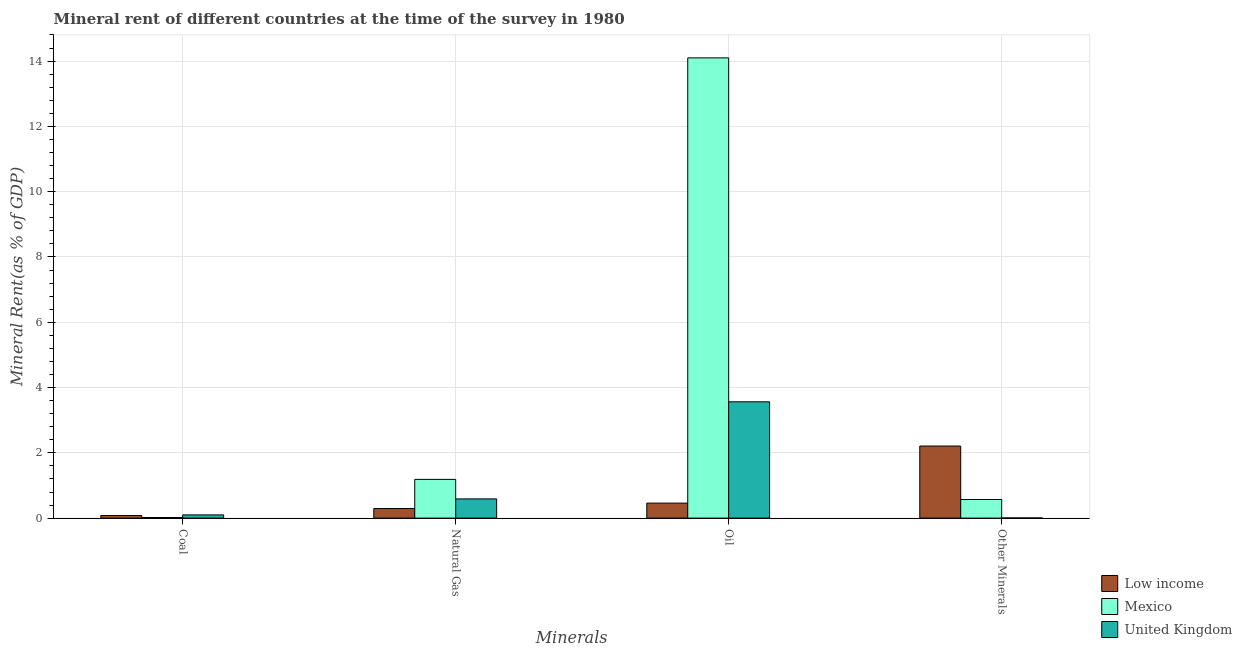How many different coloured bars are there?
Keep it short and to the point. 3. Are the number of bars on each tick of the X-axis equal?
Provide a succinct answer. Yes. What is the label of the 4th group of bars from the left?
Give a very brief answer. Other Minerals. What is the  rent of other minerals in United Kingdom?
Give a very brief answer. 0. Across all countries, what is the maximum natural gas rent?
Offer a terse response. 1.19. Across all countries, what is the minimum  rent of other minerals?
Give a very brief answer. 0. In which country was the coal rent maximum?
Give a very brief answer. United Kingdom. What is the total coal rent in the graph?
Your answer should be very brief. 0.2. What is the difference between the  rent of other minerals in Mexico and that in United Kingdom?
Your answer should be compact. 0.57. What is the difference between the oil rent in United Kingdom and the  rent of other minerals in Mexico?
Your response must be concise. 2.99. What is the average  rent of other minerals per country?
Your answer should be very brief. 0.93. What is the difference between the natural gas rent and  rent of other minerals in United Kingdom?
Provide a short and direct response. 0.58. In how many countries, is the oil rent greater than 7.6 %?
Ensure brevity in your answer.  1. What is the ratio of the natural gas rent in Low income to that in Mexico?
Offer a terse response. 0.25. What is the difference between the highest and the second highest coal rent?
Make the answer very short. 0.02. What is the difference between the highest and the lowest  rent of other minerals?
Your response must be concise. 2.2. Is it the case that in every country, the sum of the natural gas rent and  rent of other minerals is greater than the sum of coal rent and oil rent?
Give a very brief answer. No. What does the 2nd bar from the left in Oil represents?
Provide a short and direct response. Mexico. Is it the case that in every country, the sum of the coal rent and natural gas rent is greater than the oil rent?
Offer a terse response. No. Are all the bars in the graph horizontal?
Keep it short and to the point. No. What is the difference between two consecutive major ticks on the Y-axis?
Provide a succinct answer. 2. Where does the legend appear in the graph?
Provide a short and direct response. Bottom right. How many legend labels are there?
Ensure brevity in your answer.  3. How are the legend labels stacked?
Make the answer very short. Vertical. What is the title of the graph?
Make the answer very short. Mineral rent of different countries at the time of the survey in 1980. What is the label or title of the X-axis?
Your response must be concise. Minerals. What is the label or title of the Y-axis?
Ensure brevity in your answer.  Mineral Rent(as % of GDP). What is the Mineral Rent(as % of GDP) of Low income in Coal?
Your response must be concise. 0.08. What is the Mineral Rent(as % of GDP) of Mexico in Coal?
Keep it short and to the point. 0.02. What is the Mineral Rent(as % of GDP) of United Kingdom in Coal?
Give a very brief answer. 0.1. What is the Mineral Rent(as % of GDP) in Low income in Natural Gas?
Your response must be concise. 0.29. What is the Mineral Rent(as % of GDP) in Mexico in Natural Gas?
Offer a very short reply. 1.19. What is the Mineral Rent(as % of GDP) of United Kingdom in Natural Gas?
Your response must be concise. 0.59. What is the Mineral Rent(as % of GDP) in Low income in Oil?
Your answer should be very brief. 0.46. What is the Mineral Rent(as % of GDP) of Mexico in Oil?
Keep it short and to the point. 14.1. What is the Mineral Rent(as % of GDP) in United Kingdom in Oil?
Provide a short and direct response. 3.56. What is the Mineral Rent(as % of GDP) in Low income in Other Minerals?
Offer a very short reply. 2.21. What is the Mineral Rent(as % of GDP) of Mexico in Other Minerals?
Give a very brief answer. 0.57. What is the Mineral Rent(as % of GDP) in United Kingdom in Other Minerals?
Your response must be concise. 0. Across all Minerals, what is the maximum Mineral Rent(as % of GDP) in Low income?
Make the answer very short. 2.21. Across all Minerals, what is the maximum Mineral Rent(as % of GDP) of Mexico?
Provide a succinct answer. 14.1. Across all Minerals, what is the maximum Mineral Rent(as % of GDP) of United Kingdom?
Your answer should be compact. 3.56. Across all Minerals, what is the minimum Mineral Rent(as % of GDP) in Low income?
Make the answer very short. 0.08. Across all Minerals, what is the minimum Mineral Rent(as % of GDP) of Mexico?
Offer a very short reply. 0.02. Across all Minerals, what is the minimum Mineral Rent(as % of GDP) in United Kingdom?
Offer a terse response. 0. What is the total Mineral Rent(as % of GDP) in Low income in the graph?
Give a very brief answer. 3.04. What is the total Mineral Rent(as % of GDP) in Mexico in the graph?
Your answer should be compact. 15.87. What is the total Mineral Rent(as % of GDP) in United Kingdom in the graph?
Keep it short and to the point. 4.26. What is the difference between the Mineral Rent(as % of GDP) in Low income in Coal and that in Natural Gas?
Provide a short and direct response. -0.21. What is the difference between the Mineral Rent(as % of GDP) in Mexico in Coal and that in Natural Gas?
Provide a succinct answer. -1.17. What is the difference between the Mineral Rent(as % of GDP) in United Kingdom in Coal and that in Natural Gas?
Make the answer very short. -0.49. What is the difference between the Mineral Rent(as % of GDP) of Low income in Coal and that in Oil?
Give a very brief answer. -0.38. What is the difference between the Mineral Rent(as % of GDP) in Mexico in Coal and that in Oil?
Offer a very short reply. -14.08. What is the difference between the Mineral Rent(as % of GDP) in United Kingdom in Coal and that in Oil?
Offer a terse response. -3.46. What is the difference between the Mineral Rent(as % of GDP) in Low income in Coal and that in Other Minerals?
Your answer should be very brief. -2.13. What is the difference between the Mineral Rent(as % of GDP) of Mexico in Coal and that in Other Minerals?
Make the answer very short. -0.55. What is the difference between the Mineral Rent(as % of GDP) in United Kingdom in Coal and that in Other Minerals?
Offer a very short reply. 0.09. What is the difference between the Mineral Rent(as % of GDP) in Low income in Natural Gas and that in Oil?
Make the answer very short. -0.16. What is the difference between the Mineral Rent(as % of GDP) in Mexico in Natural Gas and that in Oil?
Ensure brevity in your answer.  -12.91. What is the difference between the Mineral Rent(as % of GDP) of United Kingdom in Natural Gas and that in Oil?
Provide a succinct answer. -2.97. What is the difference between the Mineral Rent(as % of GDP) of Low income in Natural Gas and that in Other Minerals?
Your answer should be compact. -1.91. What is the difference between the Mineral Rent(as % of GDP) of Mexico in Natural Gas and that in Other Minerals?
Make the answer very short. 0.62. What is the difference between the Mineral Rent(as % of GDP) in United Kingdom in Natural Gas and that in Other Minerals?
Offer a terse response. 0.58. What is the difference between the Mineral Rent(as % of GDP) in Low income in Oil and that in Other Minerals?
Offer a very short reply. -1.75. What is the difference between the Mineral Rent(as % of GDP) of Mexico in Oil and that in Other Minerals?
Keep it short and to the point. 13.53. What is the difference between the Mineral Rent(as % of GDP) of United Kingdom in Oil and that in Other Minerals?
Provide a succinct answer. 3.56. What is the difference between the Mineral Rent(as % of GDP) in Low income in Coal and the Mineral Rent(as % of GDP) in Mexico in Natural Gas?
Your response must be concise. -1.11. What is the difference between the Mineral Rent(as % of GDP) of Low income in Coal and the Mineral Rent(as % of GDP) of United Kingdom in Natural Gas?
Ensure brevity in your answer.  -0.51. What is the difference between the Mineral Rent(as % of GDP) of Mexico in Coal and the Mineral Rent(as % of GDP) of United Kingdom in Natural Gas?
Make the answer very short. -0.57. What is the difference between the Mineral Rent(as % of GDP) in Low income in Coal and the Mineral Rent(as % of GDP) in Mexico in Oil?
Your answer should be compact. -14.02. What is the difference between the Mineral Rent(as % of GDP) in Low income in Coal and the Mineral Rent(as % of GDP) in United Kingdom in Oil?
Offer a very short reply. -3.48. What is the difference between the Mineral Rent(as % of GDP) of Mexico in Coal and the Mineral Rent(as % of GDP) of United Kingdom in Oil?
Offer a terse response. -3.54. What is the difference between the Mineral Rent(as % of GDP) in Low income in Coal and the Mineral Rent(as % of GDP) in Mexico in Other Minerals?
Provide a short and direct response. -0.49. What is the difference between the Mineral Rent(as % of GDP) of Low income in Coal and the Mineral Rent(as % of GDP) of United Kingdom in Other Minerals?
Provide a short and direct response. 0.08. What is the difference between the Mineral Rent(as % of GDP) of Mexico in Coal and the Mineral Rent(as % of GDP) of United Kingdom in Other Minerals?
Make the answer very short. 0.01. What is the difference between the Mineral Rent(as % of GDP) in Low income in Natural Gas and the Mineral Rent(as % of GDP) in Mexico in Oil?
Offer a very short reply. -13.8. What is the difference between the Mineral Rent(as % of GDP) of Low income in Natural Gas and the Mineral Rent(as % of GDP) of United Kingdom in Oil?
Ensure brevity in your answer.  -3.27. What is the difference between the Mineral Rent(as % of GDP) of Mexico in Natural Gas and the Mineral Rent(as % of GDP) of United Kingdom in Oil?
Make the answer very short. -2.38. What is the difference between the Mineral Rent(as % of GDP) in Low income in Natural Gas and the Mineral Rent(as % of GDP) in Mexico in Other Minerals?
Offer a terse response. -0.28. What is the difference between the Mineral Rent(as % of GDP) of Low income in Natural Gas and the Mineral Rent(as % of GDP) of United Kingdom in Other Minerals?
Keep it short and to the point. 0.29. What is the difference between the Mineral Rent(as % of GDP) in Mexico in Natural Gas and the Mineral Rent(as % of GDP) in United Kingdom in Other Minerals?
Your answer should be very brief. 1.18. What is the difference between the Mineral Rent(as % of GDP) of Low income in Oil and the Mineral Rent(as % of GDP) of Mexico in Other Minerals?
Provide a short and direct response. -0.11. What is the difference between the Mineral Rent(as % of GDP) in Low income in Oil and the Mineral Rent(as % of GDP) in United Kingdom in Other Minerals?
Make the answer very short. 0.45. What is the difference between the Mineral Rent(as % of GDP) of Mexico in Oil and the Mineral Rent(as % of GDP) of United Kingdom in Other Minerals?
Offer a terse response. 14.09. What is the average Mineral Rent(as % of GDP) in Low income per Minerals?
Provide a short and direct response. 0.76. What is the average Mineral Rent(as % of GDP) of Mexico per Minerals?
Provide a succinct answer. 3.97. What is the average Mineral Rent(as % of GDP) of United Kingdom per Minerals?
Give a very brief answer. 1.06. What is the difference between the Mineral Rent(as % of GDP) of Low income and Mineral Rent(as % of GDP) of Mexico in Coal?
Your answer should be very brief. 0.06. What is the difference between the Mineral Rent(as % of GDP) in Low income and Mineral Rent(as % of GDP) in United Kingdom in Coal?
Provide a short and direct response. -0.02. What is the difference between the Mineral Rent(as % of GDP) of Mexico and Mineral Rent(as % of GDP) of United Kingdom in Coal?
Your response must be concise. -0.08. What is the difference between the Mineral Rent(as % of GDP) of Low income and Mineral Rent(as % of GDP) of Mexico in Natural Gas?
Your response must be concise. -0.89. What is the difference between the Mineral Rent(as % of GDP) of Low income and Mineral Rent(as % of GDP) of United Kingdom in Natural Gas?
Your response must be concise. -0.29. What is the difference between the Mineral Rent(as % of GDP) in Mexico and Mineral Rent(as % of GDP) in United Kingdom in Natural Gas?
Ensure brevity in your answer.  0.6. What is the difference between the Mineral Rent(as % of GDP) in Low income and Mineral Rent(as % of GDP) in Mexico in Oil?
Ensure brevity in your answer.  -13.64. What is the difference between the Mineral Rent(as % of GDP) in Low income and Mineral Rent(as % of GDP) in United Kingdom in Oil?
Ensure brevity in your answer.  -3.1. What is the difference between the Mineral Rent(as % of GDP) of Mexico and Mineral Rent(as % of GDP) of United Kingdom in Oil?
Offer a terse response. 10.54. What is the difference between the Mineral Rent(as % of GDP) of Low income and Mineral Rent(as % of GDP) of Mexico in Other Minerals?
Make the answer very short. 1.64. What is the difference between the Mineral Rent(as % of GDP) of Low income and Mineral Rent(as % of GDP) of United Kingdom in Other Minerals?
Your answer should be very brief. 2.2. What is the difference between the Mineral Rent(as % of GDP) of Mexico and Mineral Rent(as % of GDP) of United Kingdom in Other Minerals?
Provide a short and direct response. 0.57. What is the ratio of the Mineral Rent(as % of GDP) of Low income in Coal to that in Natural Gas?
Give a very brief answer. 0.27. What is the ratio of the Mineral Rent(as % of GDP) in Mexico in Coal to that in Natural Gas?
Ensure brevity in your answer.  0.02. What is the ratio of the Mineral Rent(as % of GDP) in United Kingdom in Coal to that in Natural Gas?
Make the answer very short. 0.17. What is the ratio of the Mineral Rent(as % of GDP) of Low income in Coal to that in Oil?
Provide a short and direct response. 0.17. What is the ratio of the Mineral Rent(as % of GDP) of Mexico in Coal to that in Oil?
Provide a short and direct response. 0. What is the ratio of the Mineral Rent(as % of GDP) of United Kingdom in Coal to that in Oil?
Your answer should be compact. 0.03. What is the ratio of the Mineral Rent(as % of GDP) of Low income in Coal to that in Other Minerals?
Keep it short and to the point. 0.04. What is the ratio of the Mineral Rent(as % of GDP) in Mexico in Coal to that in Other Minerals?
Offer a terse response. 0.03. What is the ratio of the Mineral Rent(as % of GDP) of United Kingdom in Coal to that in Other Minerals?
Provide a succinct answer. 20.4. What is the ratio of the Mineral Rent(as % of GDP) of Low income in Natural Gas to that in Oil?
Ensure brevity in your answer.  0.64. What is the ratio of the Mineral Rent(as % of GDP) in Mexico in Natural Gas to that in Oil?
Offer a very short reply. 0.08. What is the ratio of the Mineral Rent(as % of GDP) in United Kingdom in Natural Gas to that in Oil?
Make the answer very short. 0.17. What is the ratio of the Mineral Rent(as % of GDP) of Low income in Natural Gas to that in Other Minerals?
Offer a very short reply. 0.13. What is the ratio of the Mineral Rent(as % of GDP) in Mexico in Natural Gas to that in Other Minerals?
Provide a succinct answer. 2.08. What is the ratio of the Mineral Rent(as % of GDP) in United Kingdom in Natural Gas to that in Other Minerals?
Your response must be concise. 121.5. What is the ratio of the Mineral Rent(as % of GDP) of Low income in Oil to that in Other Minerals?
Provide a succinct answer. 0.21. What is the ratio of the Mineral Rent(as % of GDP) of Mexico in Oil to that in Other Minerals?
Make the answer very short. 24.71. What is the ratio of the Mineral Rent(as % of GDP) in United Kingdom in Oil to that in Other Minerals?
Offer a terse response. 735.02. What is the difference between the highest and the second highest Mineral Rent(as % of GDP) of Low income?
Provide a short and direct response. 1.75. What is the difference between the highest and the second highest Mineral Rent(as % of GDP) in Mexico?
Give a very brief answer. 12.91. What is the difference between the highest and the second highest Mineral Rent(as % of GDP) of United Kingdom?
Keep it short and to the point. 2.97. What is the difference between the highest and the lowest Mineral Rent(as % of GDP) in Low income?
Keep it short and to the point. 2.13. What is the difference between the highest and the lowest Mineral Rent(as % of GDP) of Mexico?
Offer a terse response. 14.08. What is the difference between the highest and the lowest Mineral Rent(as % of GDP) in United Kingdom?
Offer a terse response. 3.56. 